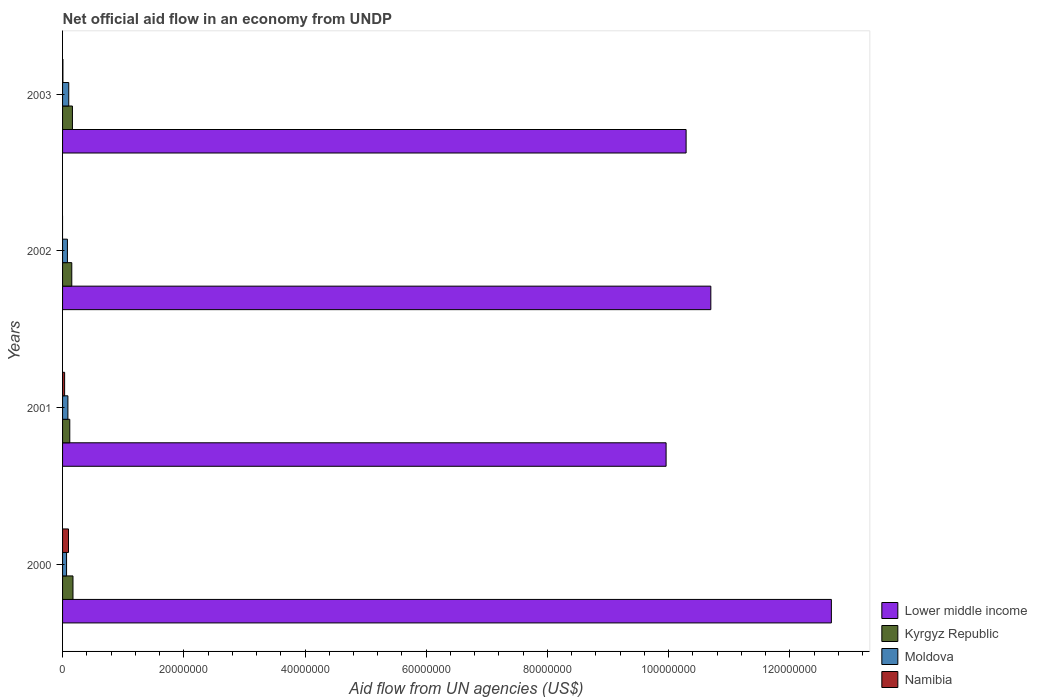How many different coloured bars are there?
Offer a terse response. 4. How many groups of bars are there?
Make the answer very short. 4. Are the number of bars per tick equal to the number of legend labels?
Make the answer very short. No. Are the number of bars on each tick of the Y-axis equal?
Provide a succinct answer. No. How many bars are there on the 3rd tick from the top?
Give a very brief answer. 4. How many bars are there on the 4th tick from the bottom?
Give a very brief answer. 4. What is the label of the 3rd group of bars from the top?
Your response must be concise. 2001. What is the net official aid flow in Moldova in 2003?
Keep it short and to the point. 1.02e+06. Across all years, what is the maximum net official aid flow in Moldova?
Your answer should be compact. 1.02e+06. In which year was the net official aid flow in Kyrgyz Republic maximum?
Provide a short and direct response. 2000. What is the total net official aid flow in Namibia in the graph?
Provide a succinct answer. 1.38e+06. What is the difference between the net official aid flow in Lower middle income in 2000 and that in 2001?
Provide a succinct answer. 2.73e+07. What is the difference between the net official aid flow in Namibia in 2000 and the net official aid flow in Lower middle income in 2001?
Provide a short and direct response. -9.86e+07. What is the average net official aid flow in Kyrgyz Republic per year?
Offer a very short reply. 1.52e+06. In the year 2002, what is the difference between the net official aid flow in Moldova and net official aid flow in Kyrgyz Republic?
Your answer should be compact. -7.20e+05. What is the ratio of the net official aid flow in Moldova in 2000 to that in 2001?
Offer a very short reply. 0.75. Is the difference between the net official aid flow in Moldova in 2002 and 2003 greater than the difference between the net official aid flow in Kyrgyz Republic in 2002 and 2003?
Give a very brief answer. No. What is the difference between the highest and the lowest net official aid flow in Namibia?
Keep it short and to the point. 9.80e+05. How many bars are there?
Offer a very short reply. 15. Are all the bars in the graph horizontal?
Offer a very short reply. Yes. How many years are there in the graph?
Provide a short and direct response. 4. What is the difference between two consecutive major ticks on the X-axis?
Ensure brevity in your answer.  2.00e+07. Are the values on the major ticks of X-axis written in scientific E-notation?
Your answer should be very brief. No. What is the title of the graph?
Offer a very short reply. Net official aid flow in an economy from UNDP. Does "Cayman Islands" appear as one of the legend labels in the graph?
Your answer should be compact. No. What is the label or title of the X-axis?
Your response must be concise. Aid flow from UN agencies (US$). What is the Aid flow from UN agencies (US$) in Lower middle income in 2000?
Offer a very short reply. 1.27e+08. What is the Aid flow from UN agencies (US$) in Kyrgyz Republic in 2000?
Keep it short and to the point. 1.72e+06. What is the Aid flow from UN agencies (US$) of Moldova in 2000?
Your answer should be compact. 6.60e+05. What is the Aid flow from UN agencies (US$) in Namibia in 2000?
Make the answer very short. 9.80e+05. What is the Aid flow from UN agencies (US$) in Lower middle income in 2001?
Make the answer very short. 9.96e+07. What is the Aid flow from UN agencies (US$) of Kyrgyz Republic in 2001?
Provide a short and direct response. 1.19e+06. What is the Aid flow from UN agencies (US$) in Moldova in 2001?
Ensure brevity in your answer.  8.80e+05. What is the Aid flow from UN agencies (US$) in Lower middle income in 2002?
Your answer should be very brief. 1.07e+08. What is the Aid flow from UN agencies (US$) of Kyrgyz Republic in 2002?
Provide a short and direct response. 1.52e+06. What is the Aid flow from UN agencies (US$) of Moldova in 2002?
Offer a very short reply. 8.00e+05. What is the Aid flow from UN agencies (US$) in Lower middle income in 2003?
Provide a succinct answer. 1.03e+08. What is the Aid flow from UN agencies (US$) in Kyrgyz Republic in 2003?
Ensure brevity in your answer.  1.63e+06. What is the Aid flow from UN agencies (US$) in Moldova in 2003?
Your response must be concise. 1.02e+06. What is the Aid flow from UN agencies (US$) in Namibia in 2003?
Provide a succinct answer. 6.00e+04. Across all years, what is the maximum Aid flow from UN agencies (US$) in Lower middle income?
Your response must be concise. 1.27e+08. Across all years, what is the maximum Aid flow from UN agencies (US$) in Kyrgyz Republic?
Provide a short and direct response. 1.72e+06. Across all years, what is the maximum Aid flow from UN agencies (US$) of Moldova?
Offer a terse response. 1.02e+06. Across all years, what is the maximum Aid flow from UN agencies (US$) in Namibia?
Your answer should be compact. 9.80e+05. Across all years, what is the minimum Aid flow from UN agencies (US$) of Lower middle income?
Provide a short and direct response. 9.96e+07. Across all years, what is the minimum Aid flow from UN agencies (US$) in Kyrgyz Republic?
Offer a very short reply. 1.19e+06. Across all years, what is the minimum Aid flow from UN agencies (US$) in Namibia?
Make the answer very short. 0. What is the total Aid flow from UN agencies (US$) of Lower middle income in the graph?
Ensure brevity in your answer.  4.36e+08. What is the total Aid flow from UN agencies (US$) of Kyrgyz Republic in the graph?
Your answer should be very brief. 6.06e+06. What is the total Aid flow from UN agencies (US$) of Moldova in the graph?
Your answer should be compact. 3.36e+06. What is the total Aid flow from UN agencies (US$) of Namibia in the graph?
Provide a short and direct response. 1.38e+06. What is the difference between the Aid flow from UN agencies (US$) in Lower middle income in 2000 and that in 2001?
Keep it short and to the point. 2.73e+07. What is the difference between the Aid flow from UN agencies (US$) in Kyrgyz Republic in 2000 and that in 2001?
Your response must be concise. 5.30e+05. What is the difference between the Aid flow from UN agencies (US$) in Namibia in 2000 and that in 2001?
Give a very brief answer. 6.40e+05. What is the difference between the Aid flow from UN agencies (US$) of Lower middle income in 2000 and that in 2002?
Your response must be concise. 1.99e+07. What is the difference between the Aid flow from UN agencies (US$) of Kyrgyz Republic in 2000 and that in 2002?
Your answer should be very brief. 2.00e+05. What is the difference between the Aid flow from UN agencies (US$) in Moldova in 2000 and that in 2002?
Keep it short and to the point. -1.40e+05. What is the difference between the Aid flow from UN agencies (US$) in Lower middle income in 2000 and that in 2003?
Keep it short and to the point. 2.40e+07. What is the difference between the Aid flow from UN agencies (US$) in Moldova in 2000 and that in 2003?
Make the answer very short. -3.60e+05. What is the difference between the Aid flow from UN agencies (US$) of Namibia in 2000 and that in 2003?
Provide a succinct answer. 9.20e+05. What is the difference between the Aid flow from UN agencies (US$) of Lower middle income in 2001 and that in 2002?
Keep it short and to the point. -7.38e+06. What is the difference between the Aid flow from UN agencies (US$) of Kyrgyz Republic in 2001 and that in 2002?
Give a very brief answer. -3.30e+05. What is the difference between the Aid flow from UN agencies (US$) of Lower middle income in 2001 and that in 2003?
Offer a very short reply. -3.30e+06. What is the difference between the Aid flow from UN agencies (US$) of Kyrgyz Republic in 2001 and that in 2003?
Your answer should be very brief. -4.40e+05. What is the difference between the Aid flow from UN agencies (US$) in Lower middle income in 2002 and that in 2003?
Keep it short and to the point. 4.08e+06. What is the difference between the Aid flow from UN agencies (US$) of Kyrgyz Republic in 2002 and that in 2003?
Provide a short and direct response. -1.10e+05. What is the difference between the Aid flow from UN agencies (US$) in Lower middle income in 2000 and the Aid flow from UN agencies (US$) in Kyrgyz Republic in 2001?
Ensure brevity in your answer.  1.26e+08. What is the difference between the Aid flow from UN agencies (US$) of Lower middle income in 2000 and the Aid flow from UN agencies (US$) of Moldova in 2001?
Offer a terse response. 1.26e+08. What is the difference between the Aid flow from UN agencies (US$) in Lower middle income in 2000 and the Aid flow from UN agencies (US$) in Namibia in 2001?
Your response must be concise. 1.27e+08. What is the difference between the Aid flow from UN agencies (US$) in Kyrgyz Republic in 2000 and the Aid flow from UN agencies (US$) in Moldova in 2001?
Provide a succinct answer. 8.40e+05. What is the difference between the Aid flow from UN agencies (US$) in Kyrgyz Republic in 2000 and the Aid flow from UN agencies (US$) in Namibia in 2001?
Your answer should be compact. 1.38e+06. What is the difference between the Aid flow from UN agencies (US$) in Lower middle income in 2000 and the Aid flow from UN agencies (US$) in Kyrgyz Republic in 2002?
Offer a very short reply. 1.25e+08. What is the difference between the Aid flow from UN agencies (US$) in Lower middle income in 2000 and the Aid flow from UN agencies (US$) in Moldova in 2002?
Offer a terse response. 1.26e+08. What is the difference between the Aid flow from UN agencies (US$) in Kyrgyz Republic in 2000 and the Aid flow from UN agencies (US$) in Moldova in 2002?
Offer a very short reply. 9.20e+05. What is the difference between the Aid flow from UN agencies (US$) in Lower middle income in 2000 and the Aid flow from UN agencies (US$) in Kyrgyz Republic in 2003?
Offer a very short reply. 1.25e+08. What is the difference between the Aid flow from UN agencies (US$) in Lower middle income in 2000 and the Aid flow from UN agencies (US$) in Moldova in 2003?
Your answer should be very brief. 1.26e+08. What is the difference between the Aid flow from UN agencies (US$) of Lower middle income in 2000 and the Aid flow from UN agencies (US$) of Namibia in 2003?
Offer a very short reply. 1.27e+08. What is the difference between the Aid flow from UN agencies (US$) in Kyrgyz Republic in 2000 and the Aid flow from UN agencies (US$) in Namibia in 2003?
Offer a terse response. 1.66e+06. What is the difference between the Aid flow from UN agencies (US$) in Moldova in 2000 and the Aid flow from UN agencies (US$) in Namibia in 2003?
Your response must be concise. 6.00e+05. What is the difference between the Aid flow from UN agencies (US$) of Lower middle income in 2001 and the Aid flow from UN agencies (US$) of Kyrgyz Republic in 2002?
Keep it short and to the point. 9.81e+07. What is the difference between the Aid flow from UN agencies (US$) in Lower middle income in 2001 and the Aid flow from UN agencies (US$) in Moldova in 2002?
Provide a succinct answer. 9.88e+07. What is the difference between the Aid flow from UN agencies (US$) in Kyrgyz Republic in 2001 and the Aid flow from UN agencies (US$) in Moldova in 2002?
Make the answer very short. 3.90e+05. What is the difference between the Aid flow from UN agencies (US$) of Lower middle income in 2001 and the Aid flow from UN agencies (US$) of Kyrgyz Republic in 2003?
Ensure brevity in your answer.  9.80e+07. What is the difference between the Aid flow from UN agencies (US$) of Lower middle income in 2001 and the Aid flow from UN agencies (US$) of Moldova in 2003?
Your answer should be compact. 9.86e+07. What is the difference between the Aid flow from UN agencies (US$) in Lower middle income in 2001 and the Aid flow from UN agencies (US$) in Namibia in 2003?
Offer a very short reply. 9.95e+07. What is the difference between the Aid flow from UN agencies (US$) of Kyrgyz Republic in 2001 and the Aid flow from UN agencies (US$) of Moldova in 2003?
Offer a very short reply. 1.70e+05. What is the difference between the Aid flow from UN agencies (US$) in Kyrgyz Republic in 2001 and the Aid flow from UN agencies (US$) in Namibia in 2003?
Make the answer very short. 1.13e+06. What is the difference between the Aid flow from UN agencies (US$) in Moldova in 2001 and the Aid flow from UN agencies (US$) in Namibia in 2003?
Your answer should be very brief. 8.20e+05. What is the difference between the Aid flow from UN agencies (US$) of Lower middle income in 2002 and the Aid flow from UN agencies (US$) of Kyrgyz Republic in 2003?
Your response must be concise. 1.05e+08. What is the difference between the Aid flow from UN agencies (US$) in Lower middle income in 2002 and the Aid flow from UN agencies (US$) in Moldova in 2003?
Offer a terse response. 1.06e+08. What is the difference between the Aid flow from UN agencies (US$) of Lower middle income in 2002 and the Aid flow from UN agencies (US$) of Namibia in 2003?
Offer a very short reply. 1.07e+08. What is the difference between the Aid flow from UN agencies (US$) in Kyrgyz Republic in 2002 and the Aid flow from UN agencies (US$) in Moldova in 2003?
Offer a terse response. 5.00e+05. What is the difference between the Aid flow from UN agencies (US$) in Kyrgyz Republic in 2002 and the Aid flow from UN agencies (US$) in Namibia in 2003?
Keep it short and to the point. 1.46e+06. What is the difference between the Aid flow from UN agencies (US$) of Moldova in 2002 and the Aid flow from UN agencies (US$) of Namibia in 2003?
Offer a terse response. 7.40e+05. What is the average Aid flow from UN agencies (US$) of Lower middle income per year?
Your answer should be very brief. 1.09e+08. What is the average Aid flow from UN agencies (US$) of Kyrgyz Republic per year?
Provide a short and direct response. 1.52e+06. What is the average Aid flow from UN agencies (US$) of Moldova per year?
Ensure brevity in your answer.  8.40e+05. What is the average Aid flow from UN agencies (US$) in Namibia per year?
Your answer should be very brief. 3.45e+05. In the year 2000, what is the difference between the Aid flow from UN agencies (US$) of Lower middle income and Aid flow from UN agencies (US$) of Kyrgyz Republic?
Ensure brevity in your answer.  1.25e+08. In the year 2000, what is the difference between the Aid flow from UN agencies (US$) of Lower middle income and Aid flow from UN agencies (US$) of Moldova?
Provide a short and direct response. 1.26e+08. In the year 2000, what is the difference between the Aid flow from UN agencies (US$) in Lower middle income and Aid flow from UN agencies (US$) in Namibia?
Give a very brief answer. 1.26e+08. In the year 2000, what is the difference between the Aid flow from UN agencies (US$) of Kyrgyz Republic and Aid flow from UN agencies (US$) of Moldova?
Provide a succinct answer. 1.06e+06. In the year 2000, what is the difference between the Aid flow from UN agencies (US$) in Kyrgyz Republic and Aid flow from UN agencies (US$) in Namibia?
Give a very brief answer. 7.40e+05. In the year 2000, what is the difference between the Aid flow from UN agencies (US$) in Moldova and Aid flow from UN agencies (US$) in Namibia?
Offer a very short reply. -3.20e+05. In the year 2001, what is the difference between the Aid flow from UN agencies (US$) of Lower middle income and Aid flow from UN agencies (US$) of Kyrgyz Republic?
Your answer should be compact. 9.84e+07. In the year 2001, what is the difference between the Aid flow from UN agencies (US$) of Lower middle income and Aid flow from UN agencies (US$) of Moldova?
Ensure brevity in your answer.  9.87e+07. In the year 2001, what is the difference between the Aid flow from UN agencies (US$) in Lower middle income and Aid flow from UN agencies (US$) in Namibia?
Provide a succinct answer. 9.92e+07. In the year 2001, what is the difference between the Aid flow from UN agencies (US$) in Kyrgyz Republic and Aid flow from UN agencies (US$) in Namibia?
Give a very brief answer. 8.50e+05. In the year 2001, what is the difference between the Aid flow from UN agencies (US$) in Moldova and Aid flow from UN agencies (US$) in Namibia?
Give a very brief answer. 5.40e+05. In the year 2002, what is the difference between the Aid flow from UN agencies (US$) of Lower middle income and Aid flow from UN agencies (US$) of Kyrgyz Republic?
Ensure brevity in your answer.  1.05e+08. In the year 2002, what is the difference between the Aid flow from UN agencies (US$) of Lower middle income and Aid flow from UN agencies (US$) of Moldova?
Provide a short and direct response. 1.06e+08. In the year 2002, what is the difference between the Aid flow from UN agencies (US$) of Kyrgyz Republic and Aid flow from UN agencies (US$) of Moldova?
Provide a short and direct response. 7.20e+05. In the year 2003, what is the difference between the Aid flow from UN agencies (US$) of Lower middle income and Aid flow from UN agencies (US$) of Kyrgyz Republic?
Make the answer very short. 1.01e+08. In the year 2003, what is the difference between the Aid flow from UN agencies (US$) in Lower middle income and Aid flow from UN agencies (US$) in Moldova?
Offer a terse response. 1.02e+08. In the year 2003, what is the difference between the Aid flow from UN agencies (US$) of Lower middle income and Aid flow from UN agencies (US$) of Namibia?
Keep it short and to the point. 1.03e+08. In the year 2003, what is the difference between the Aid flow from UN agencies (US$) in Kyrgyz Republic and Aid flow from UN agencies (US$) in Namibia?
Make the answer very short. 1.57e+06. In the year 2003, what is the difference between the Aid flow from UN agencies (US$) in Moldova and Aid flow from UN agencies (US$) in Namibia?
Your response must be concise. 9.60e+05. What is the ratio of the Aid flow from UN agencies (US$) of Lower middle income in 2000 to that in 2001?
Offer a terse response. 1.27. What is the ratio of the Aid flow from UN agencies (US$) of Kyrgyz Republic in 2000 to that in 2001?
Your response must be concise. 1.45. What is the ratio of the Aid flow from UN agencies (US$) of Moldova in 2000 to that in 2001?
Ensure brevity in your answer.  0.75. What is the ratio of the Aid flow from UN agencies (US$) of Namibia in 2000 to that in 2001?
Keep it short and to the point. 2.88. What is the ratio of the Aid flow from UN agencies (US$) in Lower middle income in 2000 to that in 2002?
Provide a short and direct response. 1.19. What is the ratio of the Aid flow from UN agencies (US$) in Kyrgyz Republic in 2000 to that in 2002?
Give a very brief answer. 1.13. What is the ratio of the Aid flow from UN agencies (US$) of Moldova in 2000 to that in 2002?
Your answer should be compact. 0.82. What is the ratio of the Aid flow from UN agencies (US$) in Lower middle income in 2000 to that in 2003?
Your answer should be compact. 1.23. What is the ratio of the Aid flow from UN agencies (US$) of Kyrgyz Republic in 2000 to that in 2003?
Provide a succinct answer. 1.06. What is the ratio of the Aid flow from UN agencies (US$) in Moldova in 2000 to that in 2003?
Your answer should be compact. 0.65. What is the ratio of the Aid flow from UN agencies (US$) in Namibia in 2000 to that in 2003?
Keep it short and to the point. 16.33. What is the ratio of the Aid flow from UN agencies (US$) of Kyrgyz Republic in 2001 to that in 2002?
Your answer should be very brief. 0.78. What is the ratio of the Aid flow from UN agencies (US$) in Moldova in 2001 to that in 2002?
Offer a very short reply. 1.1. What is the ratio of the Aid flow from UN agencies (US$) of Lower middle income in 2001 to that in 2003?
Provide a succinct answer. 0.97. What is the ratio of the Aid flow from UN agencies (US$) of Kyrgyz Republic in 2001 to that in 2003?
Offer a very short reply. 0.73. What is the ratio of the Aid flow from UN agencies (US$) of Moldova in 2001 to that in 2003?
Keep it short and to the point. 0.86. What is the ratio of the Aid flow from UN agencies (US$) of Namibia in 2001 to that in 2003?
Offer a very short reply. 5.67. What is the ratio of the Aid flow from UN agencies (US$) in Lower middle income in 2002 to that in 2003?
Offer a terse response. 1.04. What is the ratio of the Aid flow from UN agencies (US$) in Kyrgyz Republic in 2002 to that in 2003?
Provide a succinct answer. 0.93. What is the ratio of the Aid flow from UN agencies (US$) in Moldova in 2002 to that in 2003?
Offer a very short reply. 0.78. What is the difference between the highest and the second highest Aid flow from UN agencies (US$) of Lower middle income?
Provide a short and direct response. 1.99e+07. What is the difference between the highest and the second highest Aid flow from UN agencies (US$) in Kyrgyz Republic?
Ensure brevity in your answer.  9.00e+04. What is the difference between the highest and the second highest Aid flow from UN agencies (US$) of Moldova?
Make the answer very short. 1.40e+05. What is the difference between the highest and the second highest Aid flow from UN agencies (US$) of Namibia?
Ensure brevity in your answer.  6.40e+05. What is the difference between the highest and the lowest Aid flow from UN agencies (US$) of Lower middle income?
Give a very brief answer. 2.73e+07. What is the difference between the highest and the lowest Aid flow from UN agencies (US$) in Kyrgyz Republic?
Ensure brevity in your answer.  5.30e+05. What is the difference between the highest and the lowest Aid flow from UN agencies (US$) of Namibia?
Your answer should be very brief. 9.80e+05. 